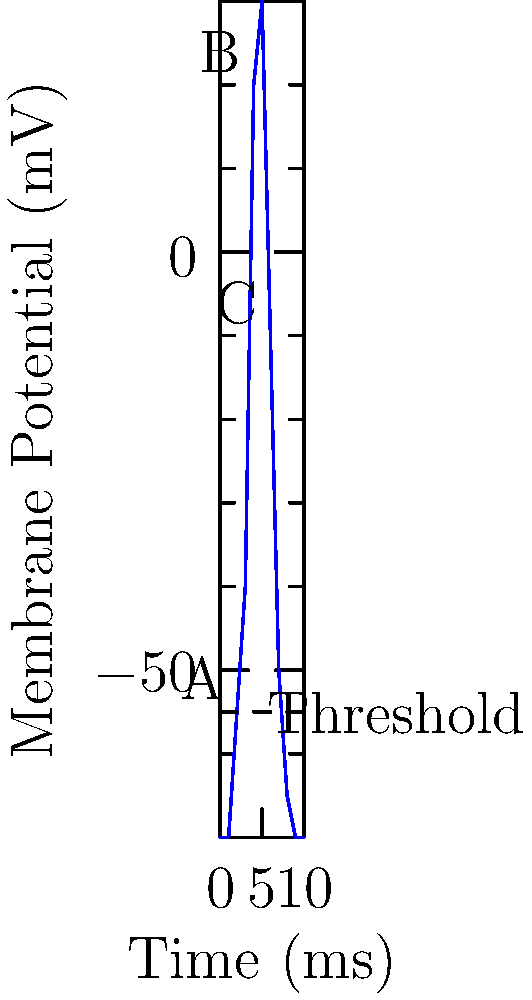Based on the time-series graph of an action potential, at which point does the sodium channels begin to close and potassium channels start to open? To answer this question, we need to understand the phases of an action potential and relate them to the graph:

1. The graph shows a typical action potential curve for a neuron.

2. The action potential has several phases:
   a. Resting state (initial flat part at -70 mV)
   b. Depolarization (rapid rise from -55 mV to +30 mV)
   c. Repolarization (rapid fall from +30 mV back towards -70 mV)
   d. Hyperpolarization (slight undershoot below -70 mV)

3. The sodium channels open during the depolarization phase, causing the rapid rise in membrane potential.

4. The sodium channels begin to close and potassium channels start to open at the peak of the action potential.

5. This point marks the transition from depolarization to repolarization.

6. On the graph, this transition occurs at point B, which is the peak of the curve at about +30 mV.

Therefore, the sodium channels begin to close and potassium channels start to open at point B on the graph.
Answer: Point B 